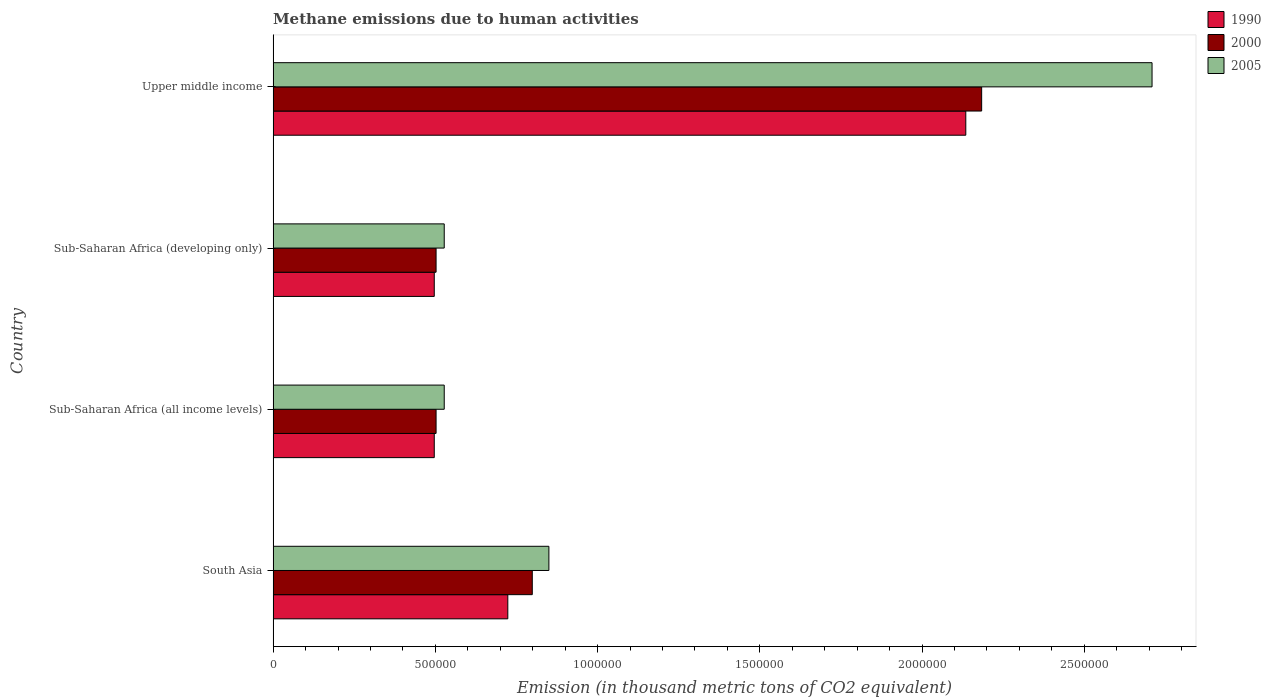How many different coloured bars are there?
Ensure brevity in your answer.  3. How many groups of bars are there?
Keep it short and to the point. 4. Are the number of bars per tick equal to the number of legend labels?
Your answer should be compact. Yes. How many bars are there on the 1st tick from the top?
Make the answer very short. 3. What is the amount of methane emitted in 2000 in South Asia?
Your answer should be compact. 7.99e+05. Across all countries, what is the maximum amount of methane emitted in 1990?
Your answer should be compact. 2.13e+06. Across all countries, what is the minimum amount of methane emitted in 1990?
Your answer should be compact. 4.97e+05. In which country was the amount of methane emitted in 1990 maximum?
Provide a short and direct response. Upper middle income. In which country was the amount of methane emitted in 1990 minimum?
Provide a succinct answer. Sub-Saharan Africa (all income levels). What is the total amount of methane emitted in 2005 in the graph?
Keep it short and to the point. 4.61e+06. What is the difference between the amount of methane emitted in 2000 in Sub-Saharan Africa (all income levels) and that in Sub-Saharan Africa (developing only)?
Provide a short and direct response. 0. What is the difference between the amount of methane emitted in 2005 in Sub-Saharan Africa (developing only) and the amount of methane emitted in 2000 in South Asia?
Your answer should be very brief. -2.71e+05. What is the average amount of methane emitted in 2005 per country?
Make the answer very short. 1.15e+06. What is the difference between the amount of methane emitted in 1990 and amount of methane emitted in 2000 in South Asia?
Offer a very short reply. -7.54e+04. In how many countries, is the amount of methane emitted in 2000 greater than 200000 thousand metric tons?
Your answer should be compact. 4. What is the ratio of the amount of methane emitted in 2005 in South Asia to that in Sub-Saharan Africa (developing only)?
Your answer should be very brief. 1.61. What is the difference between the highest and the second highest amount of methane emitted in 1990?
Your answer should be very brief. 1.41e+06. What is the difference between the highest and the lowest amount of methane emitted in 1990?
Ensure brevity in your answer.  1.64e+06. In how many countries, is the amount of methane emitted in 1990 greater than the average amount of methane emitted in 1990 taken over all countries?
Keep it short and to the point. 1. What does the 1st bar from the bottom in Upper middle income represents?
Provide a succinct answer. 1990. How many bars are there?
Make the answer very short. 12. Are all the bars in the graph horizontal?
Your answer should be very brief. Yes. Does the graph contain any zero values?
Provide a short and direct response. No. How many legend labels are there?
Provide a succinct answer. 3. What is the title of the graph?
Offer a very short reply. Methane emissions due to human activities. Does "1973" appear as one of the legend labels in the graph?
Ensure brevity in your answer.  No. What is the label or title of the X-axis?
Ensure brevity in your answer.  Emission (in thousand metric tons of CO2 equivalent). What is the Emission (in thousand metric tons of CO2 equivalent) of 1990 in South Asia?
Your answer should be compact. 7.23e+05. What is the Emission (in thousand metric tons of CO2 equivalent) of 2000 in South Asia?
Provide a short and direct response. 7.99e+05. What is the Emission (in thousand metric tons of CO2 equivalent) in 2005 in South Asia?
Make the answer very short. 8.50e+05. What is the Emission (in thousand metric tons of CO2 equivalent) of 1990 in Sub-Saharan Africa (all income levels)?
Offer a very short reply. 4.97e+05. What is the Emission (in thousand metric tons of CO2 equivalent) of 2000 in Sub-Saharan Africa (all income levels)?
Your response must be concise. 5.02e+05. What is the Emission (in thousand metric tons of CO2 equivalent) in 2005 in Sub-Saharan Africa (all income levels)?
Your answer should be compact. 5.27e+05. What is the Emission (in thousand metric tons of CO2 equivalent) of 1990 in Sub-Saharan Africa (developing only)?
Provide a succinct answer. 4.97e+05. What is the Emission (in thousand metric tons of CO2 equivalent) of 2000 in Sub-Saharan Africa (developing only)?
Your answer should be very brief. 5.02e+05. What is the Emission (in thousand metric tons of CO2 equivalent) in 2005 in Sub-Saharan Africa (developing only)?
Offer a very short reply. 5.27e+05. What is the Emission (in thousand metric tons of CO2 equivalent) of 1990 in Upper middle income?
Your answer should be compact. 2.13e+06. What is the Emission (in thousand metric tons of CO2 equivalent) of 2000 in Upper middle income?
Your answer should be compact. 2.18e+06. What is the Emission (in thousand metric tons of CO2 equivalent) in 2005 in Upper middle income?
Provide a succinct answer. 2.71e+06. Across all countries, what is the maximum Emission (in thousand metric tons of CO2 equivalent) in 1990?
Keep it short and to the point. 2.13e+06. Across all countries, what is the maximum Emission (in thousand metric tons of CO2 equivalent) of 2000?
Your answer should be compact. 2.18e+06. Across all countries, what is the maximum Emission (in thousand metric tons of CO2 equivalent) in 2005?
Provide a short and direct response. 2.71e+06. Across all countries, what is the minimum Emission (in thousand metric tons of CO2 equivalent) in 1990?
Provide a succinct answer. 4.97e+05. Across all countries, what is the minimum Emission (in thousand metric tons of CO2 equivalent) of 2000?
Offer a terse response. 5.02e+05. Across all countries, what is the minimum Emission (in thousand metric tons of CO2 equivalent) of 2005?
Your answer should be compact. 5.27e+05. What is the total Emission (in thousand metric tons of CO2 equivalent) of 1990 in the graph?
Provide a succinct answer. 3.85e+06. What is the total Emission (in thousand metric tons of CO2 equivalent) of 2000 in the graph?
Your answer should be compact. 3.99e+06. What is the total Emission (in thousand metric tons of CO2 equivalent) of 2005 in the graph?
Your answer should be very brief. 4.61e+06. What is the difference between the Emission (in thousand metric tons of CO2 equivalent) in 1990 in South Asia and that in Sub-Saharan Africa (all income levels)?
Offer a terse response. 2.27e+05. What is the difference between the Emission (in thousand metric tons of CO2 equivalent) of 2000 in South Asia and that in Sub-Saharan Africa (all income levels)?
Your response must be concise. 2.96e+05. What is the difference between the Emission (in thousand metric tons of CO2 equivalent) of 2005 in South Asia and that in Sub-Saharan Africa (all income levels)?
Give a very brief answer. 3.23e+05. What is the difference between the Emission (in thousand metric tons of CO2 equivalent) in 1990 in South Asia and that in Sub-Saharan Africa (developing only)?
Provide a succinct answer. 2.27e+05. What is the difference between the Emission (in thousand metric tons of CO2 equivalent) of 2000 in South Asia and that in Sub-Saharan Africa (developing only)?
Keep it short and to the point. 2.96e+05. What is the difference between the Emission (in thousand metric tons of CO2 equivalent) in 2005 in South Asia and that in Sub-Saharan Africa (developing only)?
Your response must be concise. 3.23e+05. What is the difference between the Emission (in thousand metric tons of CO2 equivalent) of 1990 in South Asia and that in Upper middle income?
Ensure brevity in your answer.  -1.41e+06. What is the difference between the Emission (in thousand metric tons of CO2 equivalent) of 2000 in South Asia and that in Upper middle income?
Ensure brevity in your answer.  -1.39e+06. What is the difference between the Emission (in thousand metric tons of CO2 equivalent) of 2005 in South Asia and that in Upper middle income?
Keep it short and to the point. -1.86e+06. What is the difference between the Emission (in thousand metric tons of CO2 equivalent) in 1990 in Sub-Saharan Africa (all income levels) and that in Sub-Saharan Africa (developing only)?
Give a very brief answer. 0. What is the difference between the Emission (in thousand metric tons of CO2 equivalent) of 2005 in Sub-Saharan Africa (all income levels) and that in Sub-Saharan Africa (developing only)?
Give a very brief answer. 0. What is the difference between the Emission (in thousand metric tons of CO2 equivalent) of 1990 in Sub-Saharan Africa (all income levels) and that in Upper middle income?
Give a very brief answer. -1.64e+06. What is the difference between the Emission (in thousand metric tons of CO2 equivalent) in 2000 in Sub-Saharan Africa (all income levels) and that in Upper middle income?
Keep it short and to the point. -1.68e+06. What is the difference between the Emission (in thousand metric tons of CO2 equivalent) in 2005 in Sub-Saharan Africa (all income levels) and that in Upper middle income?
Offer a terse response. -2.18e+06. What is the difference between the Emission (in thousand metric tons of CO2 equivalent) of 1990 in Sub-Saharan Africa (developing only) and that in Upper middle income?
Offer a terse response. -1.64e+06. What is the difference between the Emission (in thousand metric tons of CO2 equivalent) in 2000 in Sub-Saharan Africa (developing only) and that in Upper middle income?
Provide a succinct answer. -1.68e+06. What is the difference between the Emission (in thousand metric tons of CO2 equivalent) of 2005 in Sub-Saharan Africa (developing only) and that in Upper middle income?
Offer a very short reply. -2.18e+06. What is the difference between the Emission (in thousand metric tons of CO2 equivalent) of 1990 in South Asia and the Emission (in thousand metric tons of CO2 equivalent) of 2000 in Sub-Saharan Africa (all income levels)?
Keep it short and to the point. 2.21e+05. What is the difference between the Emission (in thousand metric tons of CO2 equivalent) of 1990 in South Asia and the Emission (in thousand metric tons of CO2 equivalent) of 2005 in Sub-Saharan Africa (all income levels)?
Ensure brevity in your answer.  1.96e+05. What is the difference between the Emission (in thousand metric tons of CO2 equivalent) in 2000 in South Asia and the Emission (in thousand metric tons of CO2 equivalent) in 2005 in Sub-Saharan Africa (all income levels)?
Offer a terse response. 2.71e+05. What is the difference between the Emission (in thousand metric tons of CO2 equivalent) in 1990 in South Asia and the Emission (in thousand metric tons of CO2 equivalent) in 2000 in Sub-Saharan Africa (developing only)?
Make the answer very short. 2.21e+05. What is the difference between the Emission (in thousand metric tons of CO2 equivalent) of 1990 in South Asia and the Emission (in thousand metric tons of CO2 equivalent) of 2005 in Sub-Saharan Africa (developing only)?
Your response must be concise. 1.96e+05. What is the difference between the Emission (in thousand metric tons of CO2 equivalent) of 2000 in South Asia and the Emission (in thousand metric tons of CO2 equivalent) of 2005 in Sub-Saharan Africa (developing only)?
Offer a terse response. 2.71e+05. What is the difference between the Emission (in thousand metric tons of CO2 equivalent) of 1990 in South Asia and the Emission (in thousand metric tons of CO2 equivalent) of 2000 in Upper middle income?
Give a very brief answer. -1.46e+06. What is the difference between the Emission (in thousand metric tons of CO2 equivalent) in 1990 in South Asia and the Emission (in thousand metric tons of CO2 equivalent) in 2005 in Upper middle income?
Offer a terse response. -1.99e+06. What is the difference between the Emission (in thousand metric tons of CO2 equivalent) of 2000 in South Asia and the Emission (in thousand metric tons of CO2 equivalent) of 2005 in Upper middle income?
Your answer should be very brief. -1.91e+06. What is the difference between the Emission (in thousand metric tons of CO2 equivalent) of 1990 in Sub-Saharan Africa (all income levels) and the Emission (in thousand metric tons of CO2 equivalent) of 2000 in Sub-Saharan Africa (developing only)?
Keep it short and to the point. -5608.2. What is the difference between the Emission (in thousand metric tons of CO2 equivalent) in 1990 in Sub-Saharan Africa (all income levels) and the Emission (in thousand metric tons of CO2 equivalent) in 2005 in Sub-Saharan Africa (developing only)?
Offer a terse response. -3.07e+04. What is the difference between the Emission (in thousand metric tons of CO2 equivalent) of 2000 in Sub-Saharan Africa (all income levels) and the Emission (in thousand metric tons of CO2 equivalent) of 2005 in Sub-Saharan Africa (developing only)?
Offer a very short reply. -2.51e+04. What is the difference between the Emission (in thousand metric tons of CO2 equivalent) in 1990 in Sub-Saharan Africa (all income levels) and the Emission (in thousand metric tons of CO2 equivalent) in 2000 in Upper middle income?
Offer a very short reply. -1.69e+06. What is the difference between the Emission (in thousand metric tons of CO2 equivalent) in 1990 in Sub-Saharan Africa (all income levels) and the Emission (in thousand metric tons of CO2 equivalent) in 2005 in Upper middle income?
Give a very brief answer. -2.21e+06. What is the difference between the Emission (in thousand metric tons of CO2 equivalent) of 2000 in Sub-Saharan Africa (all income levels) and the Emission (in thousand metric tons of CO2 equivalent) of 2005 in Upper middle income?
Provide a short and direct response. -2.21e+06. What is the difference between the Emission (in thousand metric tons of CO2 equivalent) of 1990 in Sub-Saharan Africa (developing only) and the Emission (in thousand metric tons of CO2 equivalent) of 2000 in Upper middle income?
Your response must be concise. -1.69e+06. What is the difference between the Emission (in thousand metric tons of CO2 equivalent) of 1990 in Sub-Saharan Africa (developing only) and the Emission (in thousand metric tons of CO2 equivalent) of 2005 in Upper middle income?
Provide a succinct answer. -2.21e+06. What is the difference between the Emission (in thousand metric tons of CO2 equivalent) in 2000 in Sub-Saharan Africa (developing only) and the Emission (in thousand metric tons of CO2 equivalent) in 2005 in Upper middle income?
Offer a very short reply. -2.21e+06. What is the average Emission (in thousand metric tons of CO2 equivalent) in 1990 per country?
Provide a short and direct response. 9.63e+05. What is the average Emission (in thousand metric tons of CO2 equivalent) in 2000 per country?
Provide a short and direct response. 9.97e+05. What is the average Emission (in thousand metric tons of CO2 equivalent) in 2005 per country?
Your answer should be very brief. 1.15e+06. What is the difference between the Emission (in thousand metric tons of CO2 equivalent) of 1990 and Emission (in thousand metric tons of CO2 equivalent) of 2000 in South Asia?
Your answer should be very brief. -7.54e+04. What is the difference between the Emission (in thousand metric tons of CO2 equivalent) in 1990 and Emission (in thousand metric tons of CO2 equivalent) in 2005 in South Asia?
Offer a terse response. -1.27e+05. What is the difference between the Emission (in thousand metric tons of CO2 equivalent) in 2000 and Emission (in thousand metric tons of CO2 equivalent) in 2005 in South Asia?
Give a very brief answer. -5.12e+04. What is the difference between the Emission (in thousand metric tons of CO2 equivalent) in 1990 and Emission (in thousand metric tons of CO2 equivalent) in 2000 in Sub-Saharan Africa (all income levels)?
Your answer should be compact. -5608.2. What is the difference between the Emission (in thousand metric tons of CO2 equivalent) of 1990 and Emission (in thousand metric tons of CO2 equivalent) of 2005 in Sub-Saharan Africa (all income levels)?
Offer a terse response. -3.07e+04. What is the difference between the Emission (in thousand metric tons of CO2 equivalent) in 2000 and Emission (in thousand metric tons of CO2 equivalent) in 2005 in Sub-Saharan Africa (all income levels)?
Make the answer very short. -2.51e+04. What is the difference between the Emission (in thousand metric tons of CO2 equivalent) of 1990 and Emission (in thousand metric tons of CO2 equivalent) of 2000 in Sub-Saharan Africa (developing only)?
Provide a succinct answer. -5608.2. What is the difference between the Emission (in thousand metric tons of CO2 equivalent) of 1990 and Emission (in thousand metric tons of CO2 equivalent) of 2005 in Sub-Saharan Africa (developing only)?
Offer a terse response. -3.07e+04. What is the difference between the Emission (in thousand metric tons of CO2 equivalent) of 2000 and Emission (in thousand metric tons of CO2 equivalent) of 2005 in Sub-Saharan Africa (developing only)?
Keep it short and to the point. -2.51e+04. What is the difference between the Emission (in thousand metric tons of CO2 equivalent) of 1990 and Emission (in thousand metric tons of CO2 equivalent) of 2000 in Upper middle income?
Your answer should be compact. -4.89e+04. What is the difference between the Emission (in thousand metric tons of CO2 equivalent) of 1990 and Emission (in thousand metric tons of CO2 equivalent) of 2005 in Upper middle income?
Your answer should be very brief. -5.74e+05. What is the difference between the Emission (in thousand metric tons of CO2 equivalent) in 2000 and Emission (in thousand metric tons of CO2 equivalent) in 2005 in Upper middle income?
Offer a terse response. -5.25e+05. What is the ratio of the Emission (in thousand metric tons of CO2 equivalent) in 1990 in South Asia to that in Sub-Saharan Africa (all income levels)?
Make the answer very short. 1.46. What is the ratio of the Emission (in thousand metric tons of CO2 equivalent) in 2000 in South Asia to that in Sub-Saharan Africa (all income levels)?
Give a very brief answer. 1.59. What is the ratio of the Emission (in thousand metric tons of CO2 equivalent) in 2005 in South Asia to that in Sub-Saharan Africa (all income levels)?
Give a very brief answer. 1.61. What is the ratio of the Emission (in thousand metric tons of CO2 equivalent) of 1990 in South Asia to that in Sub-Saharan Africa (developing only)?
Make the answer very short. 1.46. What is the ratio of the Emission (in thousand metric tons of CO2 equivalent) of 2000 in South Asia to that in Sub-Saharan Africa (developing only)?
Ensure brevity in your answer.  1.59. What is the ratio of the Emission (in thousand metric tons of CO2 equivalent) in 2005 in South Asia to that in Sub-Saharan Africa (developing only)?
Offer a very short reply. 1.61. What is the ratio of the Emission (in thousand metric tons of CO2 equivalent) of 1990 in South Asia to that in Upper middle income?
Offer a very short reply. 0.34. What is the ratio of the Emission (in thousand metric tons of CO2 equivalent) of 2000 in South Asia to that in Upper middle income?
Provide a short and direct response. 0.37. What is the ratio of the Emission (in thousand metric tons of CO2 equivalent) in 2005 in South Asia to that in Upper middle income?
Your answer should be compact. 0.31. What is the ratio of the Emission (in thousand metric tons of CO2 equivalent) of 1990 in Sub-Saharan Africa (all income levels) to that in Sub-Saharan Africa (developing only)?
Your answer should be very brief. 1. What is the ratio of the Emission (in thousand metric tons of CO2 equivalent) of 2005 in Sub-Saharan Africa (all income levels) to that in Sub-Saharan Africa (developing only)?
Your response must be concise. 1. What is the ratio of the Emission (in thousand metric tons of CO2 equivalent) in 1990 in Sub-Saharan Africa (all income levels) to that in Upper middle income?
Your answer should be compact. 0.23. What is the ratio of the Emission (in thousand metric tons of CO2 equivalent) of 2000 in Sub-Saharan Africa (all income levels) to that in Upper middle income?
Keep it short and to the point. 0.23. What is the ratio of the Emission (in thousand metric tons of CO2 equivalent) of 2005 in Sub-Saharan Africa (all income levels) to that in Upper middle income?
Give a very brief answer. 0.19. What is the ratio of the Emission (in thousand metric tons of CO2 equivalent) in 1990 in Sub-Saharan Africa (developing only) to that in Upper middle income?
Offer a very short reply. 0.23. What is the ratio of the Emission (in thousand metric tons of CO2 equivalent) of 2000 in Sub-Saharan Africa (developing only) to that in Upper middle income?
Your answer should be compact. 0.23. What is the ratio of the Emission (in thousand metric tons of CO2 equivalent) in 2005 in Sub-Saharan Africa (developing only) to that in Upper middle income?
Your response must be concise. 0.19. What is the difference between the highest and the second highest Emission (in thousand metric tons of CO2 equivalent) of 1990?
Your answer should be very brief. 1.41e+06. What is the difference between the highest and the second highest Emission (in thousand metric tons of CO2 equivalent) of 2000?
Offer a terse response. 1.39e+06. What is the difference between the highest and the second highest Emission (in thousand metric tons of CO2 equivalent) of 2005?
Keep it short and to the point. 1.86e+06. What is the difference between the highest and the lowest Emission (in thousand metric tons of CO2 equivalent) of 1990?
Your answer should be compact. 1.64e+06. What is the difference between the highest and the lowest Emission (in thousand metric tons of CO2 equivalent) in 2000?
Provide a short and direct response. 1.68e+06. What is the difference between the highest and the lowest Emission (in thousand metric tons of CO2 equivalent) of 2005?
Offer a very short reply. 2.18e+06. 